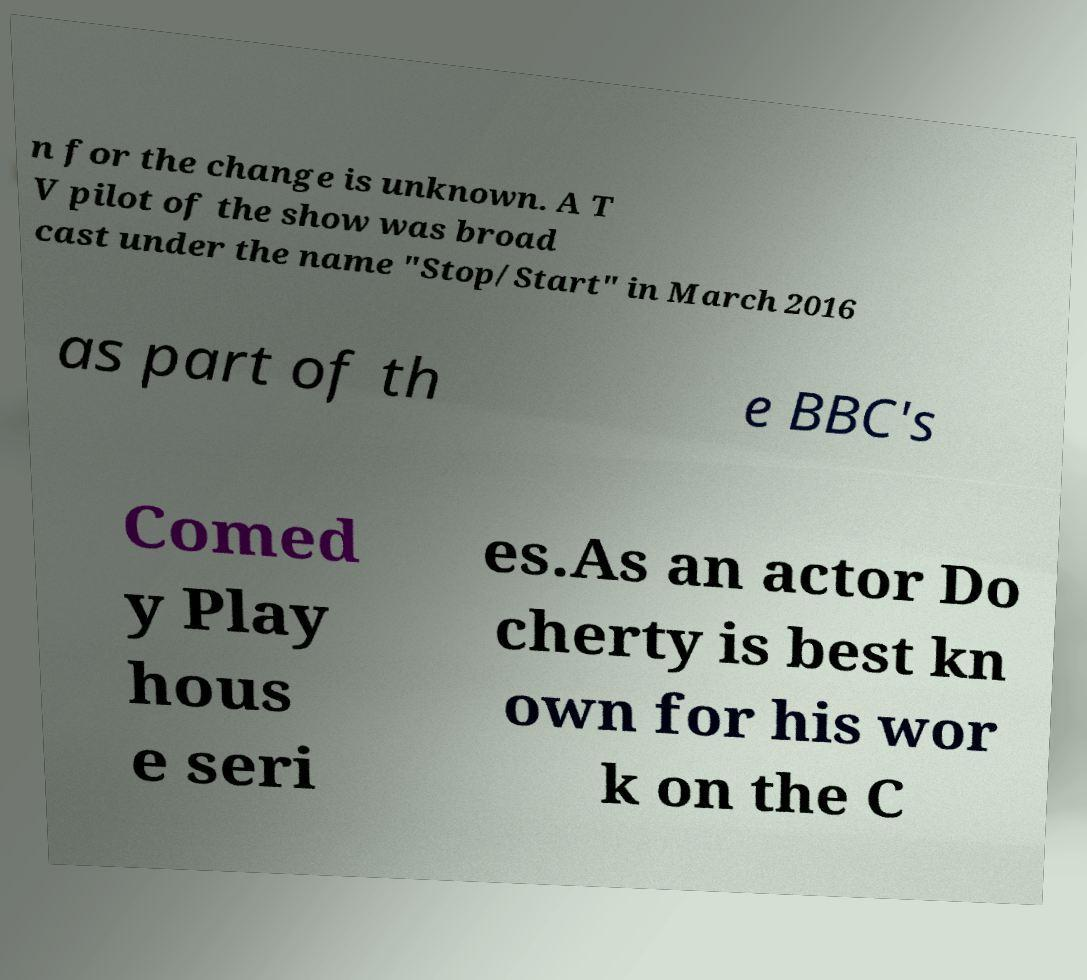Could you extract and type out the text from this image? n for the change is unknown. A T V pilot of the show was broad cast under the name "Stop/Start" in March 2016 as part of th e BBC's Comed y Play hous e seri es.As an actor Do cherty is best kn own for his wor k on the C 